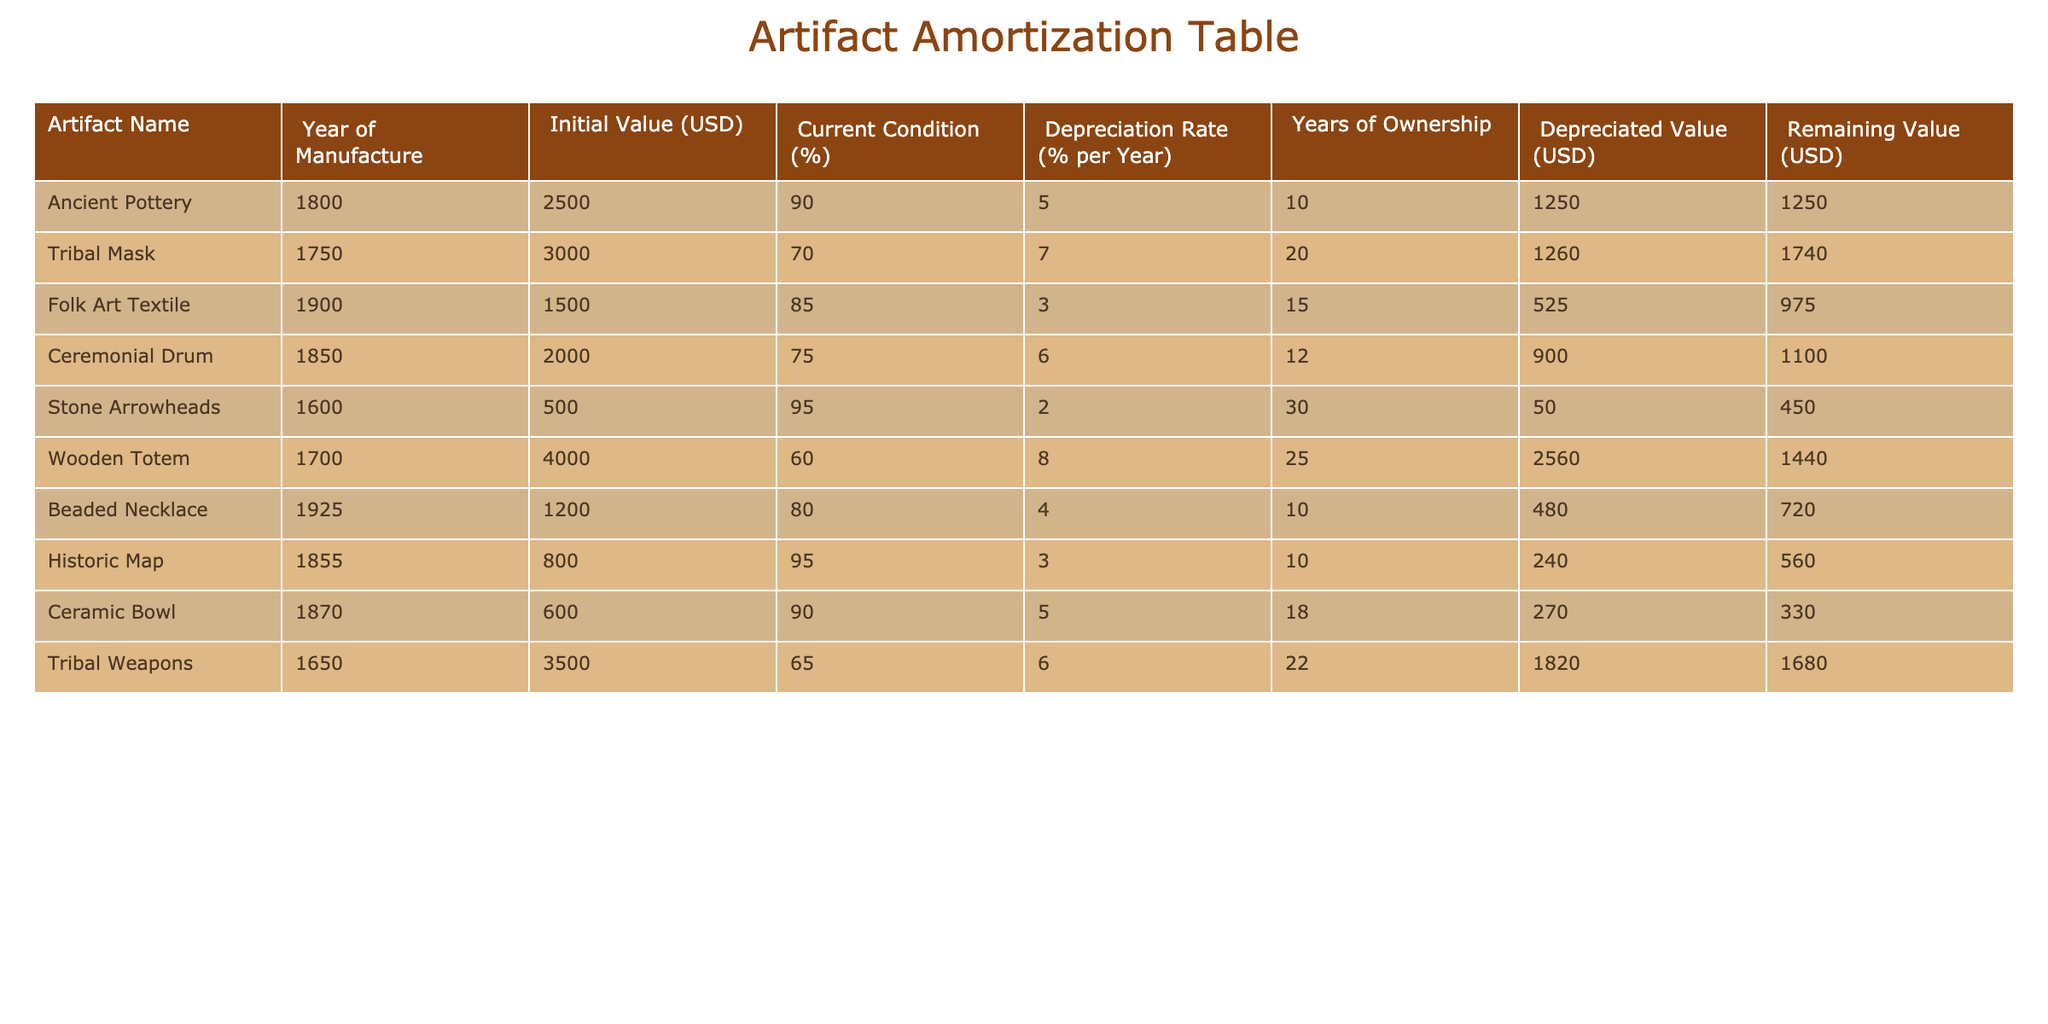What is the current condition percentage of the Tribal Mask? The table lists the condition percentage for each artifact. By locating the row for the Tribal Mask, we see that its current condition percentage is 70.
Answer: 70 Which artifact has the highest depreciated value? Looking through the "Depreciated Value (USD)" column, we identify the values and see that the Wooden Totem has the highest depreciated value at 2560.
Answer: Wooden Totem What is the total initial value of all the artifacts? To find the total initial value, we add up the Initial Value for each artifact: 2500 + 3000 + 1500 + 2000 + 500 + 4000 + 1200 + 800 + 600 + 3500 = 18300.
Answer: 18300 Is the Beaded Necklace currently worth more than the Folk Art Textile? To answer, we compare the Remaining Value for both artifacts. The Beaded Necklace's Remaining Value is 720 while the Folk Art Textile's is 975. Since 720 is less than 975, the answer is no.
Answer: No What is the difference in remaining value between the Stone Arrowheads and the Ceremonial Drum? To find the difference, we subtract the Remaining Value of the Stone Arrowheads (450) from that of the Ceremonial Drum (1100): 1100 - 450 = 650.
Answer: 650 Which two artifacts have the lowest current condition percentages, and what are those percentages? By examining the Current Condition (%) column, we see the Tribal Mask at 70 and the Wooden Totem at 60. Thus, these two artifacts have the lowest condition percentages of 70 and 60.
Answer: 70 and 60 What is the average depreciated value of the artifacts owned for 10 years? First, we identify the artifacts owned for 10 years, which are the Ancient Pottery and the Historic Map with depreciated values of 1250 and 240. The sum is 1250 + 240 = 1490, and the average is 1490 divided by 2 = 745.
Answer: 745 Does the Folk Art Textile have a lower depreciation rate than the Tribal Mask? The Folk Art Textile has a depreciation rate of 15%, while the Tribal Mask's rate is 7%. Since 15% is higher than 7%, the answer is no.
Answer: No How many artifacts have a depreciated value greater than 1000? By filtering the Depreciated Value column, we find that the following artifacts have values greater than 1000: Wooden Totem (2560), Tribal Weapons (1820), and Ceremonial Drum (900, does not count), leading to a total of 3 artifacts.
Answer: 3 